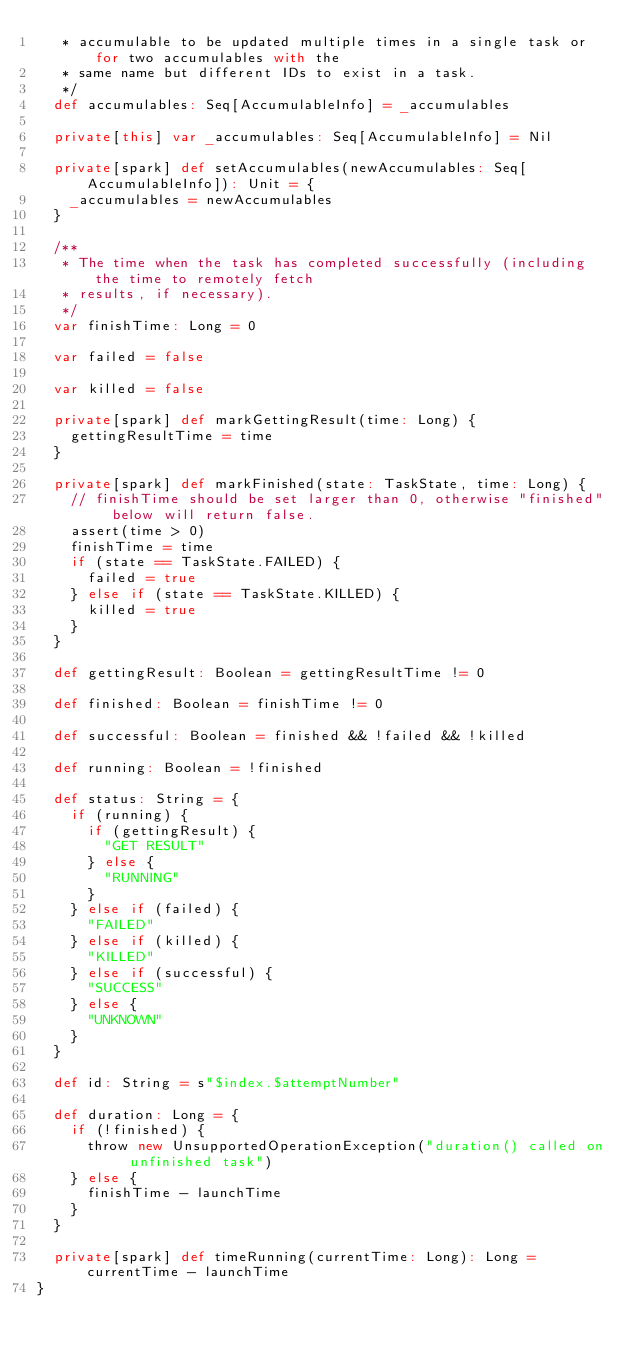Convert code to text. <code><loc_0><loc_0><loc_500><loc_500><_Scala_>   * accumulable to be updated multiple times in a single task or for two accumulables with the
   * same name but different IDs to exist in a task.
   */
  def accumulables: Seq[AccumulableInfo] = _accumulables

  private[this] var _accumulables: Seq[AccumulableInfo] = Nil

  private[spark] def setAccumulables(newAccumulables: Seq[AccumulableInfo]): Unit = {
    _accumulables = newAccumulables
  }

  /**
   * The time when the task has completed successfully (including the time to remotely fetch
   * results, if necessary).
   */
  var finishTime: Long = 0

  var failed = false

  var killed = false

  private[spark] def markGettingResult(time: Long) {
    gettingResultTime = time
  }

  private[spark] def markFinished(state: TaskState, time: Long) {
    // finishTime should be set larger than 0, otherwise "finished" below will return false.
    assert(time > 0)
    finishTime = time
    if (state == TaskState.FAILED) {
      failed = true
    } else if (state == TaskState.KILLED) {
      killed = true
    }
  }

  def gettingResult: Boolean = gettingResultTime != 0

  def finished: Boolean = finishTime != 0

  def successful: Boolean = finished && !failed && !killed

  def running: Boolean = !finished

  def status: String = {
    if (running) {
      if (gettingResult) {
        "GET RESULT"
      } else {
        "RUNNING"
      }
    } else if (failed) {
      "FAILED"
    } else if (killed) {
      "KILLED"
    } else if (successful) {
      "SUCCESS"
    } else {
      "UNKNOWN"
    }
  }

  def id: String = s"$index.$attemptNumber"

  def duration: Long = {
    if (!finished) {
      throw new UnsupportedOperationException("duration() called on unfinished task")
    } else {
      finishTime - launchTime
    }
  }

  private[spark] def timeRunning(currentTime: Long): Long = currentTime - launchTime
}
</code> 